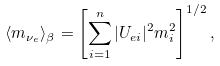<formula> <loc_0><loc_0><loc_500><loc_500>\langle m _ { \nu _ { e } } \rangle _ { \beta } = \left [ \sum _ { i = 1 } ^ { n } | U _ { e i } | ^ { 2 } m _ { i } ^ { 2 } \right ] ^ { 1 / 2 } ,</formula> 